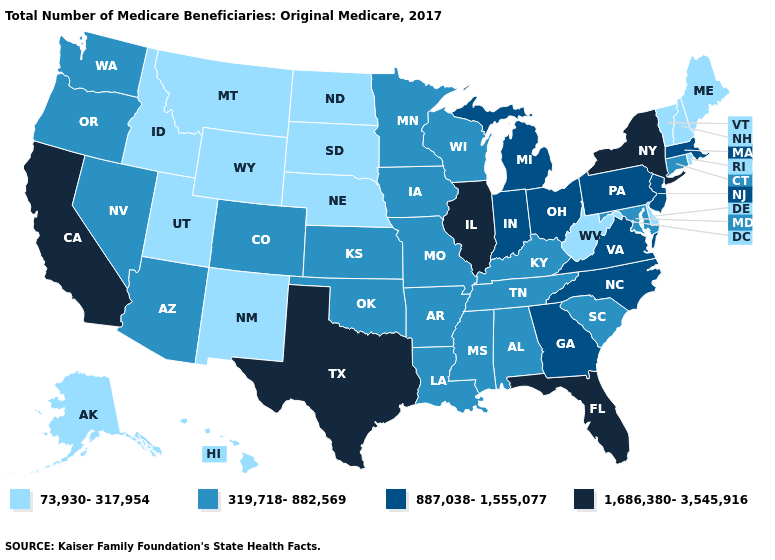Among the states that border Kentucky , which have the highest value?
Write a very short answer. Illinois. What is the lowest value in states that border Pennsylvania?
Short answer required. 73,930-317,954. Name the states that have a value in the range 1,686,380-3,545,916?
Be succinct. California, Florida, Illinois, New York, Texas. Does Arkansas have the lowest value in the USA?
Give a very brief answer. No. Which states have the highest value in the USA?
Give a very brief answer. California, Florida, Illinois, New York, Texas. What is the highest value in states that border Nevada?
Give a very brief answer. 1,686,380-3,545,916. Does the map have missing data?
Answer briefly. No. What is the value of Louisiana?
Quick response, please. 319,718-882,569. Among the states that border Georgia , does Florida have the highest value?
Answer briefly. Yes. Does California have the highest value in the USA?
Short answer required. Yes. What is the value of Wyoming?
Keep it brief. 73,930-317,954. What is the lowest value in the USA?
Answer briefly. 73,930-317,954. Name the states that have a value in the range 319,718-882,569?
Short answer required. Alabama, Arizona, Arkansas, Colorado, Connecticut, Iowa, Kansas, Kentucky, Louisiana, Maryland, Minnesota, Mississippi, Missouri, Nevada, Oklahoma, Oregon, South Carolina, Tennessee, Washington, Wisconsin. Name the states that have a value in the range 319,718-882,569?
Write a very short answer. Alabama, Arizona, Arkansas, Colorado, Connecticut, Iowa, Kansas, Kentucky, Louisiana, Maryland, Minnesota, Mississippi, Missouri, Nevada, Oklahoma, Oregon, South Carolina, Tennessee, Washington, Wisconsin. Does New York have the highest value in the USA?
Give a very brief answer. Yes. 